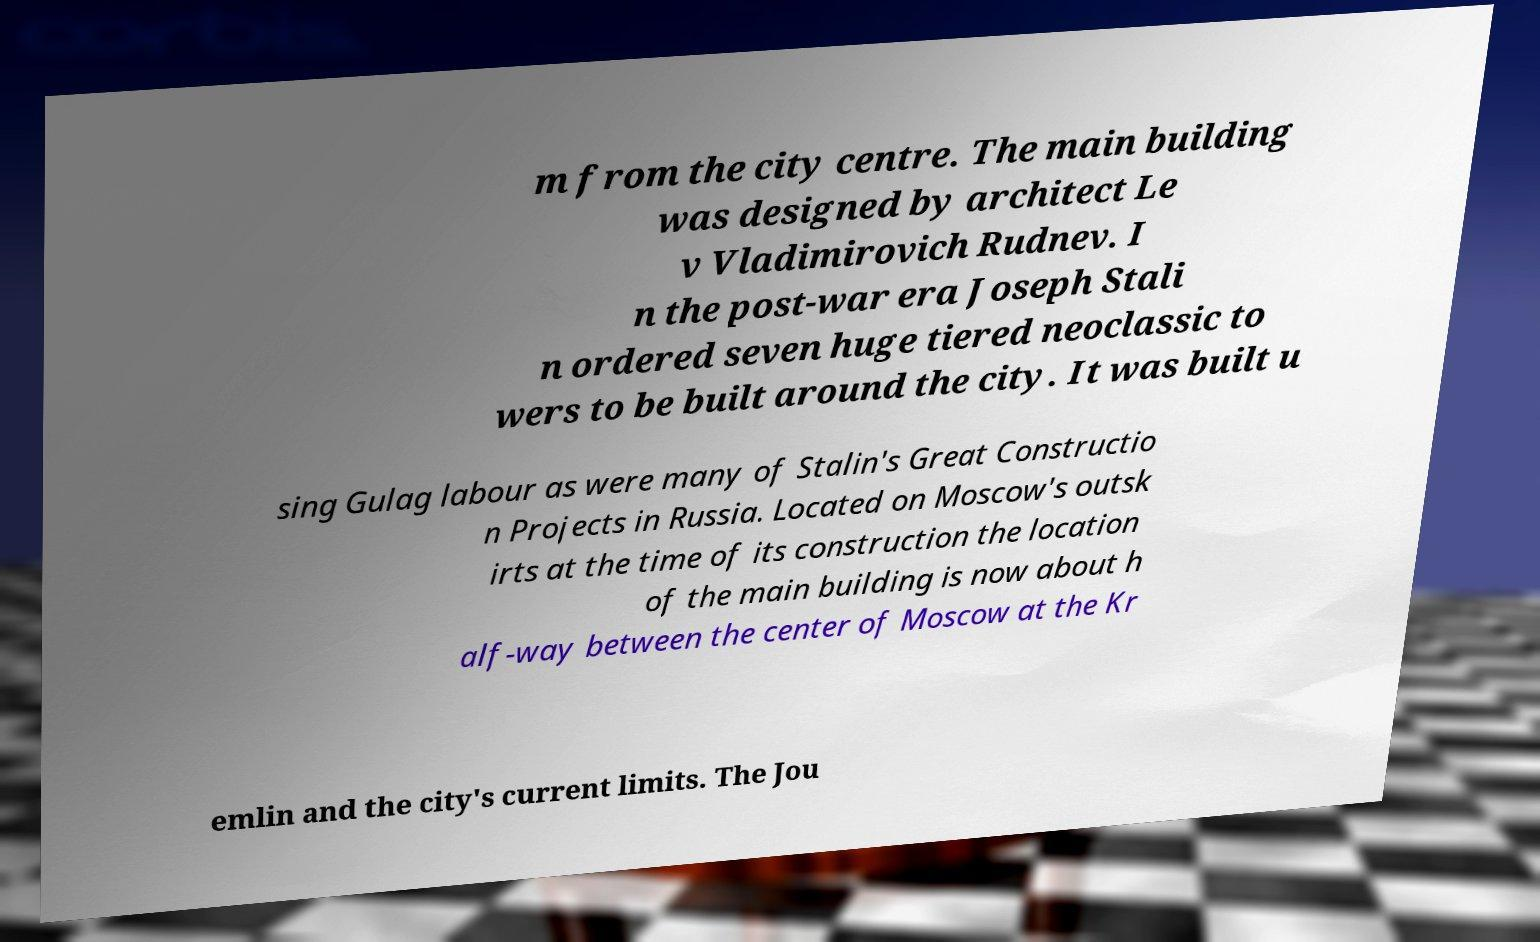I need the written content from this picture converted into text. Can you do that? m from the city centre. The main building was designed by architect Le v Vladimirovich Rudnev. I n the post-war era Joseph Stali n ordered seven huge tiered neoclassic to wers to be built around the city. It was built u sing Gulag labour as were many of Stalin's Great Constructio n Projects in Russia. Located on Moscow's outsk irts at the time of its construction the location of the main building is now about h alf-way between the center of Moscow at the Kr emlin and the city's current limits. The Jou 